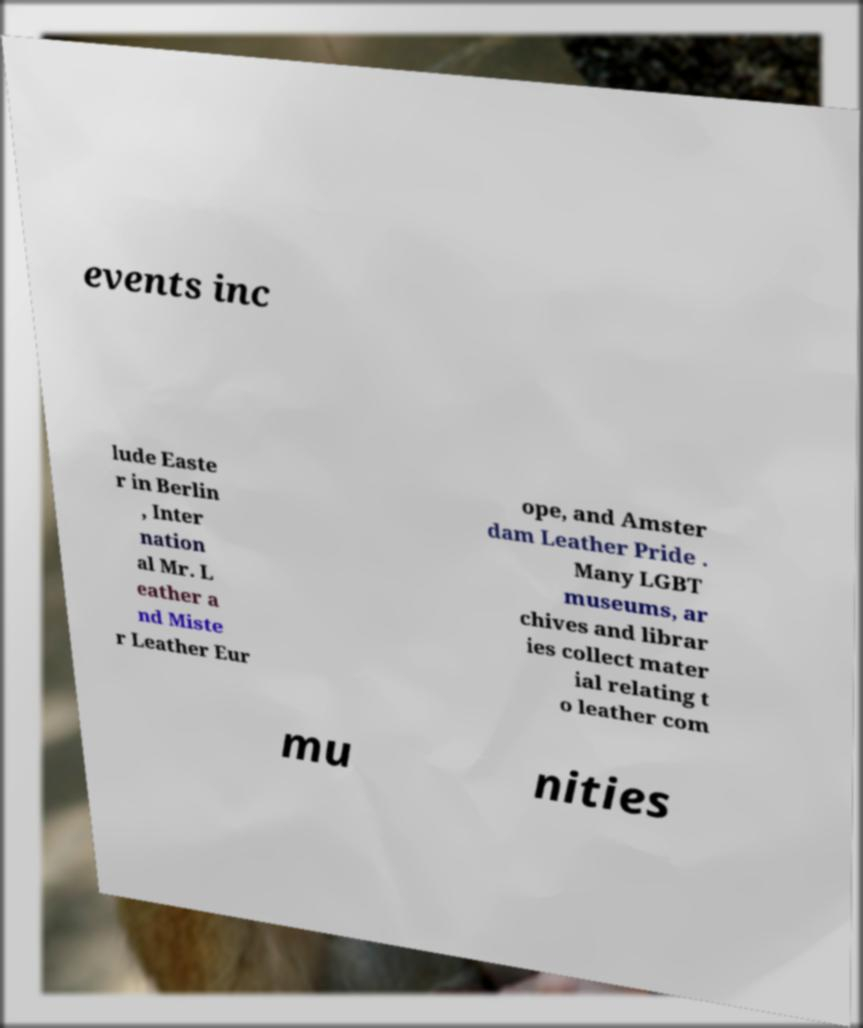Please read and relay the text visible in this image. What does it say? events inc lude Easte r in Berlin , Inter nation al Mr. L eather a nd Miste r Leather Eur ope, and Amster dam Leather Pride . Many LGBT museums, ar chives and librar ies collect mater ial relating t o leather com mu nities 